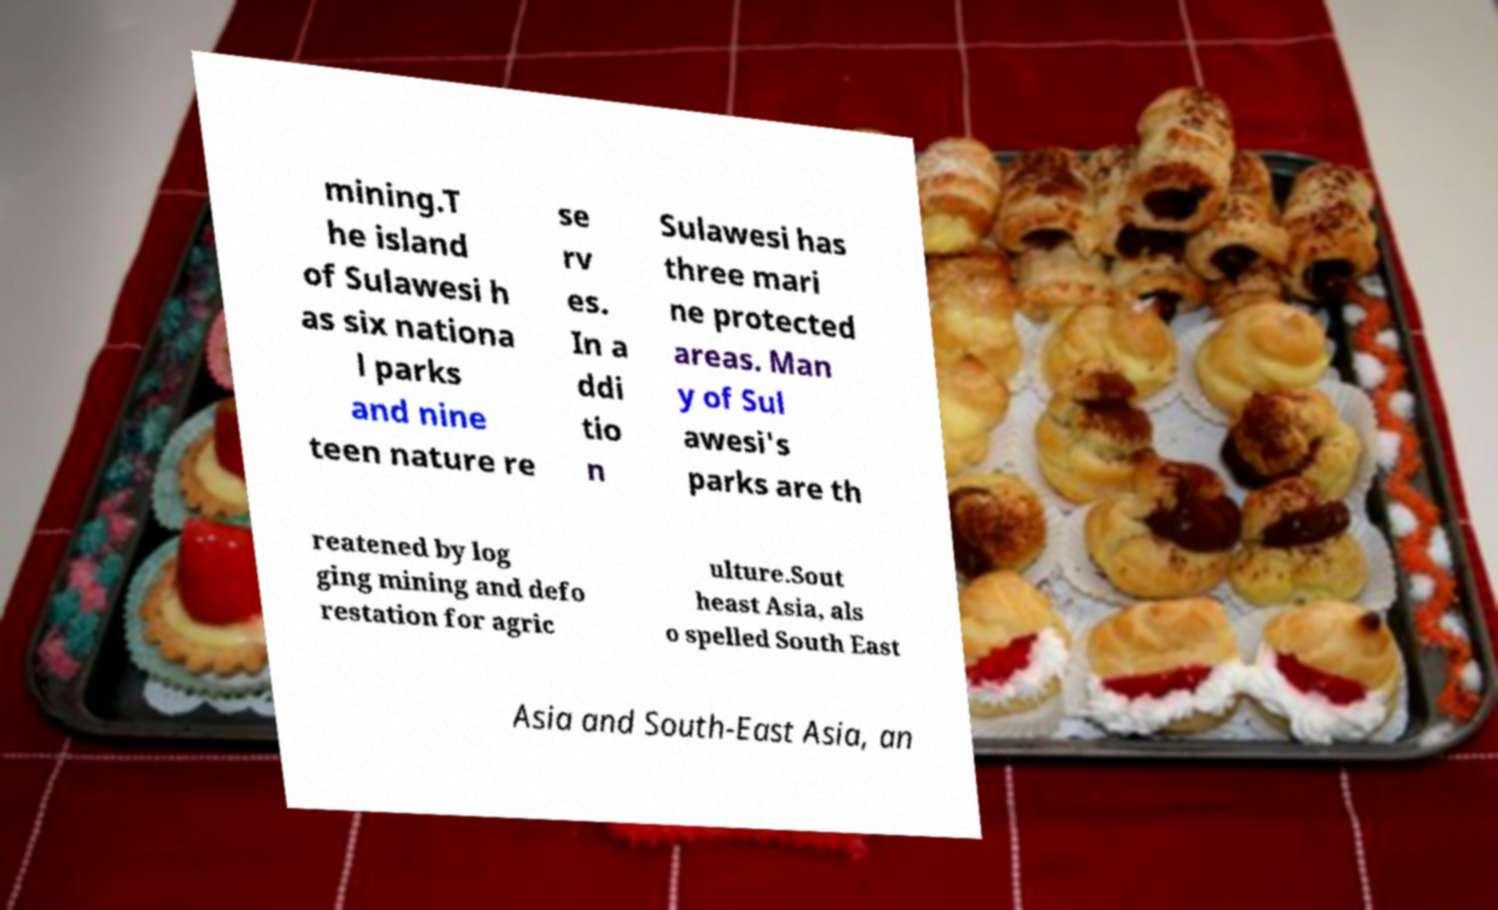Can you read and provide the text displayed in the image?This photo seems to have some interesting text. Can you extract and type it out for me? mining.T he island of Sulawesi h as six nationa l parks and nine teen nature re se rv es. In a ddi tio n Sulawesi has three mari ne protected areas. Man y of Sul awesi's parks are th reatened by log ging mining and defo restation for agric ulture.Sout heast Asia, als o spelled South East Asia and South-East Asia, an 